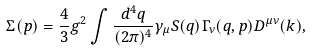Convert formula to latex. <formula><loc_0><loc_0><loc_500><loc_500>\Sigma ( p ) = \frac { 4 } { 3 } g ^ { 2 } \int \frac { d ^ { 4 } q } { ( 2 \pi ) ^ { 4 } } \gamma _ { \mu } S ( q ) \Gamma _ { \nu } ( q , p ) D ^ { \mu \nu } ( k ) ,</formula> 